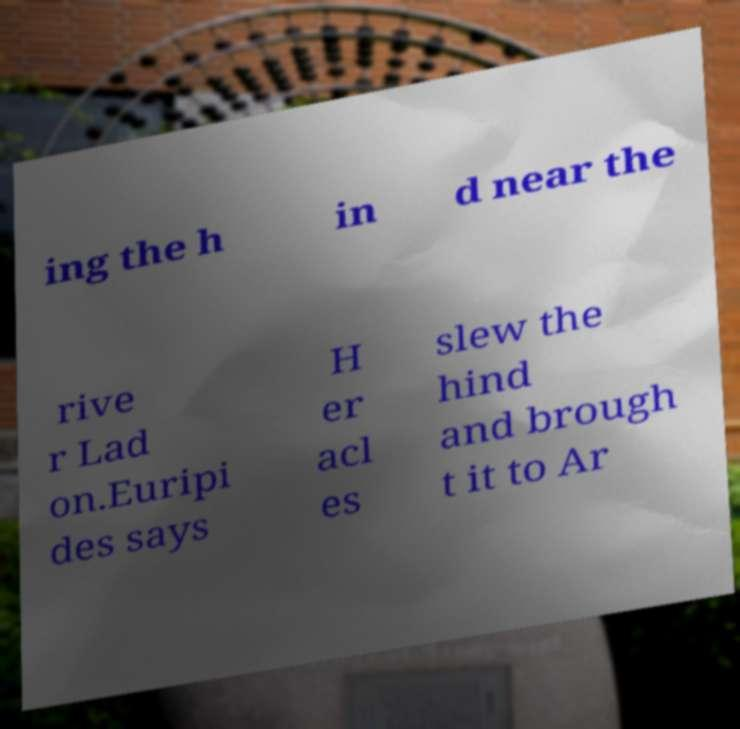Can you read and provide the text displayed in the image?This photo seems to have some interesting text. Can you extract and type it out for me? ing the h in d near the rive r Lad on.Euripi des says H er acl es slew the hind and brough t it to Ar 